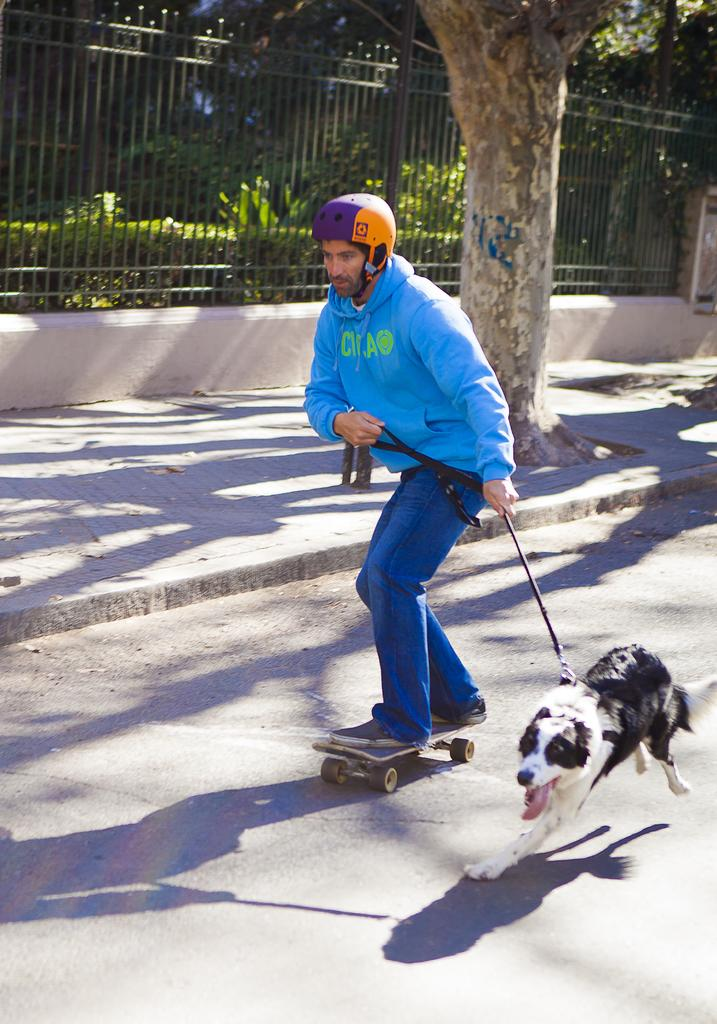What is the person in the image doing? There is a person skating in the image. What is the person holding while skating? The person is holding a dog. Where are the person and dog located? They are on the road. What can be seen in the background of the image? There is a tree, fencing, plants, and grass in the background of the image. What type of kitty can be seen playing with a leaf in the image? There is no kitty or leaf present in the image; it features a person skating with a dog on the road. 